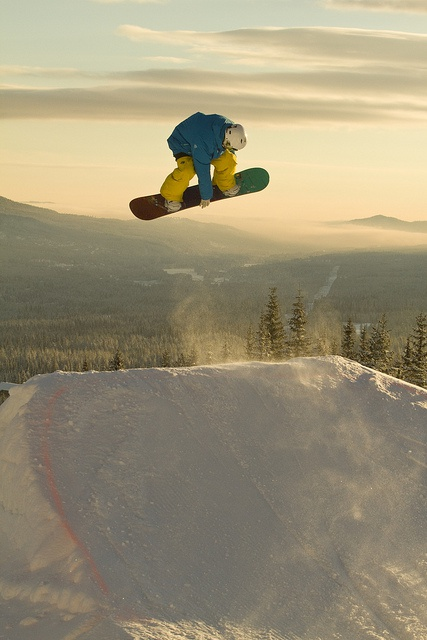Describe the objects in this image and their specific colors. I can see people in beige, blue, darkblue, and olive tones and snowboard in beige, black, darkgreen, maroon, and olive tones in this image. 